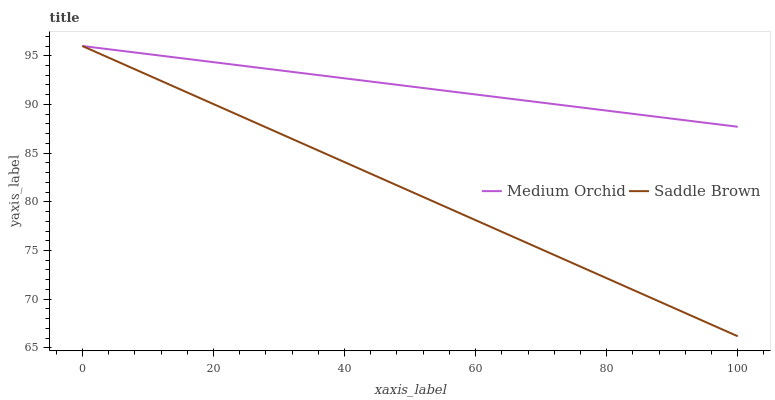Does Saddle Brown have the minimum area under the curve?
Answer yes or no. Yes. Does Medium Orchid have the maximum area under the curve?
Answer yes or no. Yes. Does Saddle Brown have the maximum area under the curve?
Answer yes or no. No. Is Medium Orchid the smoothest?
Answer yes or no. Yes. Is Saddle Brown the roughest?
Answer yes or no. Yes. Is Saddle Brown the smoothest?
Answer yes or no. No. Does Saddle Brown have the lowest value?
Answer yes or no. Yes. Does Saddle Brown have the highest value?
Answer yes or no. Yes. Does Saddle Brown intersect Medium Orchid?
Answer yes or no. Yes. Is Saddle Brown less than Medium Orchid?
Answer yes or no. No. Is Saddle Brown greater than Medium Orchid?
Answer yes or no. No. 